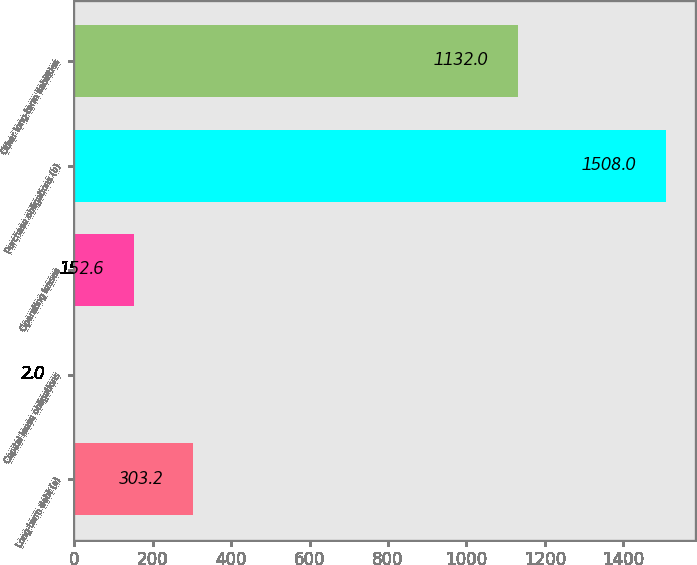<chart> <loc_0><loc_0><loc_500><loc_500><bar_chart><fcel>Long-term debt (a)<fcel>Capital lease obligations<fcel>Operating leases<fcel>Purchase obligations (b)<fcel>Other long-term liabilities<nl><fcel>303.2<fcel>2<fcel>152.6<fcel>1508<fcel>1132<nl></chart> 